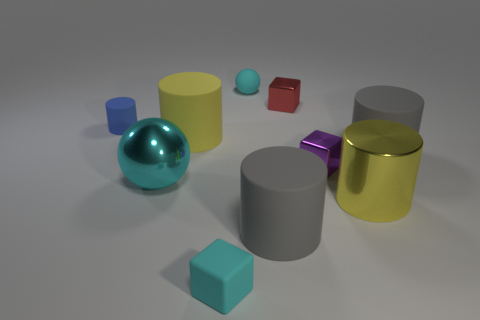Describe the lighting in the scene. The lighting in the scene is diffused, giving the image a soft appearance with subtle shadows under each object, indicating an overhead light source, possibly with a broad spread. 